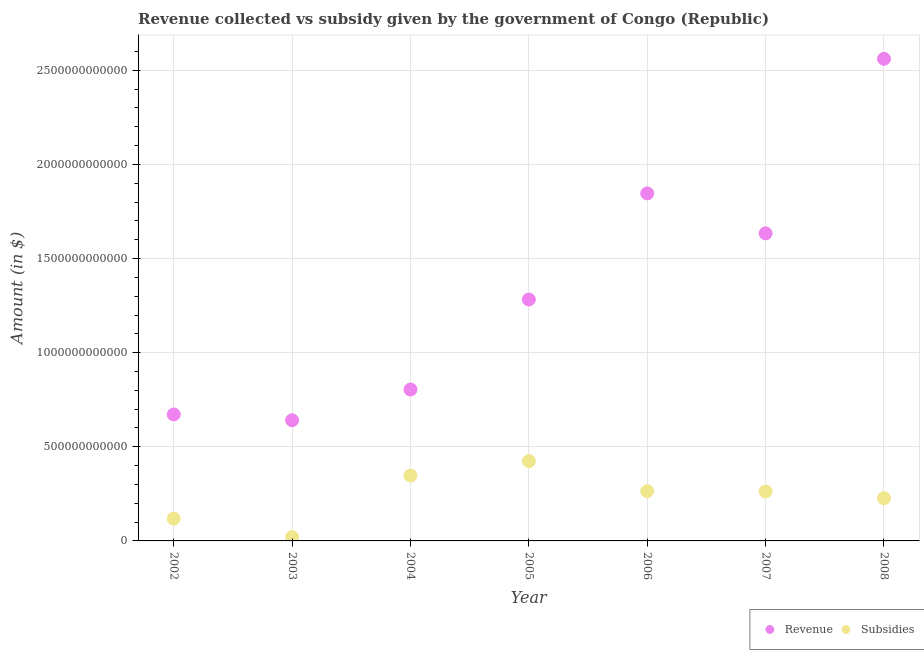Is the number of dotlines equal to the number of legend labels?
Provide a short and direct response. Yes. What is the amount of subsidies given in 2005?
Make the answer very short. 4.24e+11. Across all years, what is the maximum amount of revenue collected?
Your answer should be compact. 2.56e+12. Across all years, what is the minimum amount of subsidies given?
Give a very brief answer. 2.05e+1. In which year was the amount of revenue collected maximum?
Offer a terse response. 2008. What is the total amount of revenue collected in the graph?
Provide a succinct answer. 9.44e+12. What is the difference between the amount of revenue collected in 2005 and that in 2006?
Give a very brief answer. -5.64e+11. What is the difference between the amount of revenue collected in 2007 and the amount of subsidies given in 2002?
Your answer should be compact. 1.52e+12. What is the average amount of subsidies given per year?
Your answer should be compact. 2.38e+11. In the year 2003, what is the difference between the amount of subsidies given and amount of revenue collected?
Your response must be concise. -6.21e+11. What is the ratio of the amount of revenue collected in 2002 to that in 2005?
Provide a succinct answer. 0.52. What is the difference between the highest and the second highest amount of subsidies given?
Your answer should be compact. 7.68e+1. What is the difference between the highest and the lowest amount of revenue collected?
Offer a very short reply. 1.92e+12. In how many years, is the amount of subsidies given greater than the average amount of subsidies given taken over all years?
Make the answer very short. 4. Does the amount of revenue collected monotonically increase over the years?
Offer a terse response. No. Is the amount of subsidies given strictly less than the amount of revenue collected over the years?
Provide a short and direct response. Yes. How many years are there in the graph?
Your answer should be very brief. 7. What is the difference between two consecutive major ticks on the Y-axis?
Make the answer very short. 5.00e+11. Are the values on the major ticks of Y-axis written in scientific E-notation?
Your answer should be very brief. No. Does the graph contain grids?
Your response must be concise. Yes. How many legend labels are there?
Your answer should be compact. 2. What is the title of the graph?
Ensure brevity in your answer.  Revenue collected vs subsidy given by the government of Congo (Republic). What is the label or title of the Y-axis?
Provide a short and direct response. Amount (in $). What is the Amount (in $) of Revenue in 2002?
Provide a succinct answer. 6.72e+11. What is the Amount (in $) in Subsidies in 2002?
Your answer should be compact. 1.19e+11. What is the Amount (in $) of Revenue in 2003?
Keep it short and to the point. 6.41e+11. What is the Amount (in $) of Subsidies in 2003?
Your answer should be very brief. 2.05e+1. What is the Amount (in $) of Revenue in 2004?
Ensure brevity in your answer.  8.04e+11. What is the Amount (in $) in Subsidies in 2004?
Offer a terse response. 3.47e+11. What is the Amount (in $) in Revenue in 2005?
Your response must be concise. 1.28e+12. What is the Amount (in $) of Subsidies in 2005?
Provide a short and direct response. 4.24e+11. What is the Amount (in $) of Revenue in 2006?
Your response must be concise. 1.85e+12. What is the Amount (in $) of Subsidies in 2006?
Provide a short and direct response. 2.64e+11. What is the Amount (in $) of Revenue in 2007?
Keep it short and to the point. 1.63e+12. What is the Amount (in $) of Subsidies in 2007?
Provide a succinct answer. 2.62e+11. What is the Amount (in $) of Revenue in 2008?
Your response must be concise. 2.56e+12. What is the Amount (in $) in Subsidies in 2008?
Offer a terse response. 2.27e+11. Across all years, what is the maximum Amount (in $) in Revenue?
Give a very brief answer. 2.56e+12. Across all years, what is the maximum Amount (in $) in Subsidies?
Provide a succinct answer. 4.24e+11. Across all years, what is the minimum Amount (in $) of Revenue?
Provide a succinct answer. 6.41e+11. Across all years, what is the minimum Amount (in $) of Subsidies?
Your answer should be compact. 2.05e+1. What is the total Amount (in $) of Revenue in the graph?
Offer a very short reply. 9.44e+12. What is the total Amount (in $) in Subsidies in the graph?
Keep it short and to the point. 1.66e+12. What is the difference between the Amount (in $) in Revenue in 2002 and that in 2003?
Make the answer very short. 3.06e+1. What is the difference between the Amount (in $) in Subsidies in 2002 and that in 2003?
Offer a very short reply. 9.81e+1. What is the difference between the Amount (in $) in Revenue in 2002 and that in 2004?
Give a very brief answer. -1.32e+11. What is the difference between the Amount (in $) of Subsidies in 2002 and that in 2004?
Give a very brief answer. -2.28e+11. What is the difference between the Amount (in $) of Revenue in 2002 and that in 2005?
Your response must be concise. -6.11e+11. What is the difference between the Amount (in $) of Subsidies in 2002 and that in 2005?
Make the answer very short. -3.05e+11. What is the difference between the Amount (in $) of Revenue in 2002 and that in 2006?
Your answer should be very brief. -1.17e+12. What is the difference between the Amount (in $) in Subsidies in 2002 and that in 2006?
Provide a succinct answer. -1.46e+11. What is the difference between the Amount (in $) of Revenue in 2002 and that in 2007?
Provide a short and direct response. -9.62e+11. What is the difference between the Amount (in $) in Subsidies in 2002 and that in 2007?
Ensure brevity in your answer.  -1.44e+11. What is the difference between the Amount (in $) in Revenue in 2002 and that in 2008?
Offer a terse response. -1.89e+12. What is the difference between the Amount (in $) of Subsidies in 2002 and that in 2008?
Give a very brief answer. -1.08e+11. What is the difference between the Amount (in $) in Revenue in 2003 and that in 2004?
Your answer should be compact. -1.63e+11. What is the difference between the Amount (in $) of Subsidies in 2003 and that in 2004?
Give a very brief answer. -3.26e+11. What is the difference between the Amount (in $) in Revenue in 2003 and that in 2005?
Provide a succinct answer. -6.41e+11. What is the difference between the Amount (in $) in Subsidies in 2003 and that in 2005?
Provide a succinct answer. -4.03e+11. What is the difference between the Amount (in $) of Revenue in 2003 and that in 2006?
Ensure brevity in your answer.  -1.20e+12. What is the difference between the Amount (in $) of Subsidies in 2003 and that in 2006?
Your answer should be very brief. -2.44e+11. What is the difference between the Amount (in $) of Revenue in 2003 and that in 2007?
Make the answer very short. -9.93e+11. What is the difference between the Amount (in $) of Subsidies in 2003 and that in 2007?
Provide a succinct answer. -2.42e+11. What is the difference between the Amount (in $) of Revenue in 2003 and that in 2008?
Ensure brevity in your answer.  -1.92e+12. What is the difference between the Amount (in $) of Subsidies in 2003 and that in 2008?
Provide a succinct answer. -2.06e+11. What is the difference between the Amount (in $) of Revenue in 2004 and that in 2005?
Keep it short and to the point. -4.78e+11. What is the difference between the Amount (in $) in Subsidies in 2004 and that in 2005?
Keep it short and to the point. -7.68e+1. What is the difference between the Amount (in $) in Revenue in 2004 and that in 2006?
Your answer should be very brief. -1.04e+12. What is the difference between the Amount (in $) of Subsidies in 2004 and that in 2006?
Your answer should be very brief. 8.27e+1. What is the difference between the Amount (in $) in Revenue in 2004 and that in 2007?
Ensure brevity in your answer.  -8.29e+11. What is the difference between the Amount (in $) of Subsidies in 2004 and that in 2007?
Make the answer very short. 8.45e+1. What is the difference between the Amount (in $) in Revenue in 2004 and that in 2008?
Provide a succinct answer. -1.76e+12. What is the difference between the Amount (in $) of Subsidies in 2004 and that in 2008?
Make the answer very short. 1.20e+11. What is the difference between the Amount (in $) in Revenue in 2005 and that in 2006?
Offer a very short reply. -5.64e+11. What is the difference between the Amount (in $) of Subsidies in 2005 and that in 2006?
Ensure brevity in your answer.  1.60e+11. What is the difference between the Amount (in $) in Revenue in 2005 and that in 2007?
Your answer should be very brief. -3.51e+11. What is the difference between the Amount (in $) of Subsidies in 2005 and that in 2007?
Offer a very short reply. 1.61e+11. What is the difference between the Amount (in $) of Revenue in 2005 and that in 2008?
Offer a very short reply. -1.28e+12. What is the difference between the Amount (in $) in Subsidies in 2005 and that in 2008?
Your response must be concise. 1.97e+11. What is the difference between the Amount (in $) in Revenue in 2006 and that in 2007?
Your response must be concise. 2.12e+11. What is the difference between the Amount (in $) in Subsidies in 2006 and that in 2007?
Ensure brevity in your answer.  1.88e+09. What is the difference between the Amount (in $) in Revenue in 2006 and that in 2008?
Ensure brevity in your answer.  -7.15e+11. What is the difference between the Amount (in $) in Subsidies in 2006 and that in 2008?
Ensure brevity in your answer.  3.74e+1. What is the difference between the Amount (in $) of Revenue in 2007 and that in 2008?
Offer a very short reply. -9.27e+11. What is the difference between the Amount (in $) in Subsidies in 2007 and that in 2008?
Your answer should be compact. 3.55e+1. What is the difference between the Amount (in $) in Revenue in 2002 and the Amount (in $) in Subsidies in 2003?
Offer a very short reply. 6.51e+11. What is the difference between the Amount (in $) of Revenue in 2002 and the Amount (in $) of Subsidies in 2004?
Keep it short and to the point. 3.25e+11. What is the difference between the Amount (in $) of Revenue in 2002 and the Amount (in $) of Subsidies in 2005?
Provide a succinct answer. 2.48e+11. What is the difference between the Amount (in $) of Revenue in 2002 and the Amount (in $) of Subsidies in 2006?
Your answer should be very brief. 4.07e+11. What is the difference between the Amount (in $) in Revenue in 2002 and the Amount (in $) in Subsidies in 2007?
Ensure brevity in your answer.  4.09e+11. What is the difference between the Amount (in $) in Revenue in 2002 and the Amount (in $) in Subsidies in 2008?
Your response must be concise. 4.45e+11. What is the difference between the Amount (in $) of Revenue in 2003 and the Amount (in $) of Subsidies in 2004?
Your answer should be very brief. 2.94e+11. What is the difference between the Amount (in $) in Revenue in 2003 and the Amount (in $) in Subsidies in 2005?
Offer a very short reply. 2.17e+11. What is the difference between the Amount (in $) of Revenue in 2003 and the Amount (in $) of Subsidies in 2006?
Your answer should be very brief. 3.77e+11. What is the difference between the Amount (in $) of Revenue in 2003 and the Amount (in $) of Subsidies in 2007?
Your response must be concise. 3.79e+11. What is the difference between the Amount (in $) of Revenue in 2003 and the Amount (in $) of Subsidies in 2008?
Offer a very short reply. 4.14e+11. What is the difference between the Amount (in $) of Revenue in 2004 and the Amount (in $) of Subsidies in 2005?
Your answer should be very brief. 3.80e+11. What is the difference between the Amount (in $) in Revenue in 2004 and the Amount (in $) in Subsidies in 2006?
Your answer should be very brief. 5.40e+11. What is the difference between the Amount (in $) in Revenue in 2004 and the Amount (in $) in Subsidies in 2007?
Your answer should be very brief. 5.42e+11. What is the difference between the Amount (in $) of Revenue in 2004 and the Amount (in $) of Subsidies in 2008?
Your response must be concise. 5.77e+11. What is the difference between the Amount (in $) of Revenue in 2005 and the Amount (in $) of Subsidies in 2006?
Ensure brevity in your answer.  1.02e+12. What is the difference between the Amount (in $) of Revenue in 2005 and the Amount (in $) of Subsidies in 2007?
Offer a very short reply. 1.02e+12. What is the difference between the Amount (in $) in Revenue in 2005 and the Amount (in $) in Subsidies in 2008?
Offer a very short reply. 1.06e+12. What is the difference between the Amount (in $) in Revenue in 2006 and the Amount (in $) in Subsidies in 2007?
Keep it short and to the point. 1.58e+12. What is the difference between the Amount (in $) of Revenue in 2006 and the Amount (in $) of Subsidies in 2008?
Offer a terse response. 1.62e+12. What is the difference between the Amount (in $) in Revenue in 2007 and the Amount (in $) in Subsidies in 2008?
Give a very brief answer. 1.41e+12. What is the average Amount (in $) of Revenue per year?
Your answer should be compact. 1.35e+12. What is the average Amount (in $) of Subsidies per year?
Provide a short and direct response. 2.38e+11. In the year 2002, what is the difference between the Amount (in $) of Revenue and Amount (in $) of Subsidies?
Your response must be concise. 5.53e+11. In the year 2003, what is the difference between the Amount (in $) in Revenue and Amount (in $) in Subsidies?
Offer a very short reply. 6.21e+11. In the year 2004, what is the difference between the Amount (in $) of Revenue and Amount (in $) of Subsidies?
Keep it short and to the point. 4.57e+11. In the year 2005, what is the difference between the Amount (in $) in Revenue and Amount (in $) in Subsidies?
Offer a terse response. 8.58e+11. In the year 2006, what is the difference between the Amount (in $) of Revenue and Amount (in $) of Subsidies?
Give a very brief answer. 1.58e+12. In the year 2007, what is the difference between the Amount (in $) in Revenue and Amount (in $) in Subsidies?
Provide a succinct answer. 1.37e+12. In the year 2008, what is the difference between the Amount (in $) of Revenue and Amount (in $) of Subsidies?
Keep it short and to the point. 2.33e+12. What is the ratio of the Amount (in $) of Revenue in 2002 to that in 2003?
Offer a very short reply. 1.05. What is the ratio of the Amount (in $) in Subsidies in 2002 to that in 2003?
Provide a short and direct response. 5.78. What is the ratio of the Amount (in $) of Revenue in 2002 to that in 2004?
Provide a succinct answer. 0.84. What is the ratio of the Amount (in $) in Subsidies in 2002 to that in 2004?
Offer a terse response. 0.34. What is the ratio of the Amount (in $) in Revenue in 2002 to that in 2005?
Provide a short and direct response. 0.52. What is the ratio of the Amount (in $) in Subsidies in 2002 to that in 2005?
Offer a terse response. 0.28. What is the ratio of the Amount (in $) of Revenue in 2002 to that in 2006?
Make the answer very short. 0.36. What is the ratio of the Amount (in $) in Subsidies in 2002 to that in 2006?
Offer a terse response. 0.45. What is the ratio of the Amount (in $) of Revenue in 2002 to that in 2007?
Your answer should be compact. 0.41. What is the ratio of the Amount (in $) in Subsidies in 2002 to that in 2007?
Keep it short and to the point. 0.45. What is the ratio of the Amount (in $) in Revenue in 2002 to that in 2008?
Keep it short and to the point. 0.26. What is the ratio of the Amount (in $) in Subsidies in 2002 to that in 2008?
Ensure brevity in your answer.  0.52. What is the ratio of the Amount (in $) of Revenue in 2003 to that in 2004?
Give a very brief answer. 0.8. What is the ratio of the Amount (in $) of Subsidies in 2003 to that in 2004?
Ensure brevity in your answer.  0.06. What is the ratio of the Amount (in $) in Revenue in 2003 to that in 2005?
Your answer should be compact. 0.5. What is the ratio of the Amount (in $) in Subsidies in 2003 to that in 2005?
Your response must be concise. 0.05. What is the ratio of the Amount (in $) in Revenue in 2003 to that in 2006?
Your answer should be very brief. 0.35. What is the ratio of the Amount (in $) of Subsidies in 2003 to that in 2006?
Provide a succinct answer. 0.08. What is the ratio of the Amount (in $) in Revenue in 2003 to that in 2007?
Make the answer very short. 0.39. What is the ratio of the Amount (in $) in Subsidies in 2003 to that in 2007?
Your answer should be compact. 0.08. What is the ratio of the Amount (in $) in Revenue in 2003 to that in 2008?
Offer a very short reply. 0.25. What is the ratio of the Amount (in $) in Subsidies in 2003 to that in 2008?
Ensure brevity in your answer.  0.09. What is the ratio of the Amount (in $) in Revenue in 2004 to that in 2005?
Your answer should be very brief. 0.63. What is the ratio of the Amount (in $) in Subsidies in 2004 to that in 2005?
Your answer should be very brief. 0.82. What is the ratio of the Amount (in $) of Revenue in 2004 to that in 2006?
Offer a very short reply. 0.44. What is the ratio of the Amount (in $) in Subsidies in 2004 to that in 2006?
Your response must be concise. 1.31. What is the ratio of the Amount (in $) of Revenue in 2004 to that in 2007?
Ensure brevity in your answer.  0.49. What is the ratio of the Amount (in $) of Subsidies in 2004 to that in 2007?
Your answer should be very brief. 1.32. What is the ratio of the Amount (in $) of Revenue in 2004 to that in 2008?
Provide a short and direct response. 0.31. What is the ratio of the Amount (in $) in Subsidies in 2004 to that in 2008?
Offer a terse response. 1.53. What is the ratio of the Amount (in $) in Revenue in 2005 to that in 2006?
Keep it short and to the point. 0.69. What is the ratio of the Amount (in $) in Subsidies in 2005 to that in 2006?
Provide a succinct answer. 1.6. What is the ratio of the Amount (in $) in Revenue in 2005 to that in 2007?
Your response must be concise. 0.78. What is the ratio of the Amount (in $) in Subsidies in 2005 to that in 2007?
Make the answer very short. 1.61. What is the ratio of the Amount (in $) of Revenue in 2005 to that in 2008?
Your answer should be very brief. 0.5. What is the ratio of the Amount (in $) in Subsidies in 2005 to that in 2008?
Offer a terse response. 1.87. What is the ratio of the Amount (in $) in Revenue in 2006 to that in 2007?
Your answer should be compact. 1.13. What is the ratio of the Amount (in $) of Subsidies in 2006 to that in 2007?
Your answer should be very brief. 1.01. What is the ratio of the Amount (in $) in Revenue in 2006 to that in 2008?
Your answer should be very brief. 0.72. What is the ratio of the Amount (in $) of Subsidies in 2006 to that in 2008?
Make the answer very short. 1.16. What is the ratio of the Amount (in $) in Revenue in 2007 to that in 2008?
Offer a very short reply. 0.64. What is the ratio of the Amount (in $) in Subsidies in 2007 to that in 2008?
Provide a succinct answer. 1.16. What is the difference between the highest and the second highest Amount (in $) in Revenue?
Keep it short and to the point. 7.15e+11. What is the difference between the highest and the second highest Amount (in $) in Subsidies?
Make the answer very short. 7.68e+1. What is the difference between the highest and the lowest Amount (in $) of Revenue?
Keep it short and to the point. 1.92e+12. What is the difference between the highest and the lowest Amount (in $) in Subsidies?
Make the answer very short. 4.03e+11. 